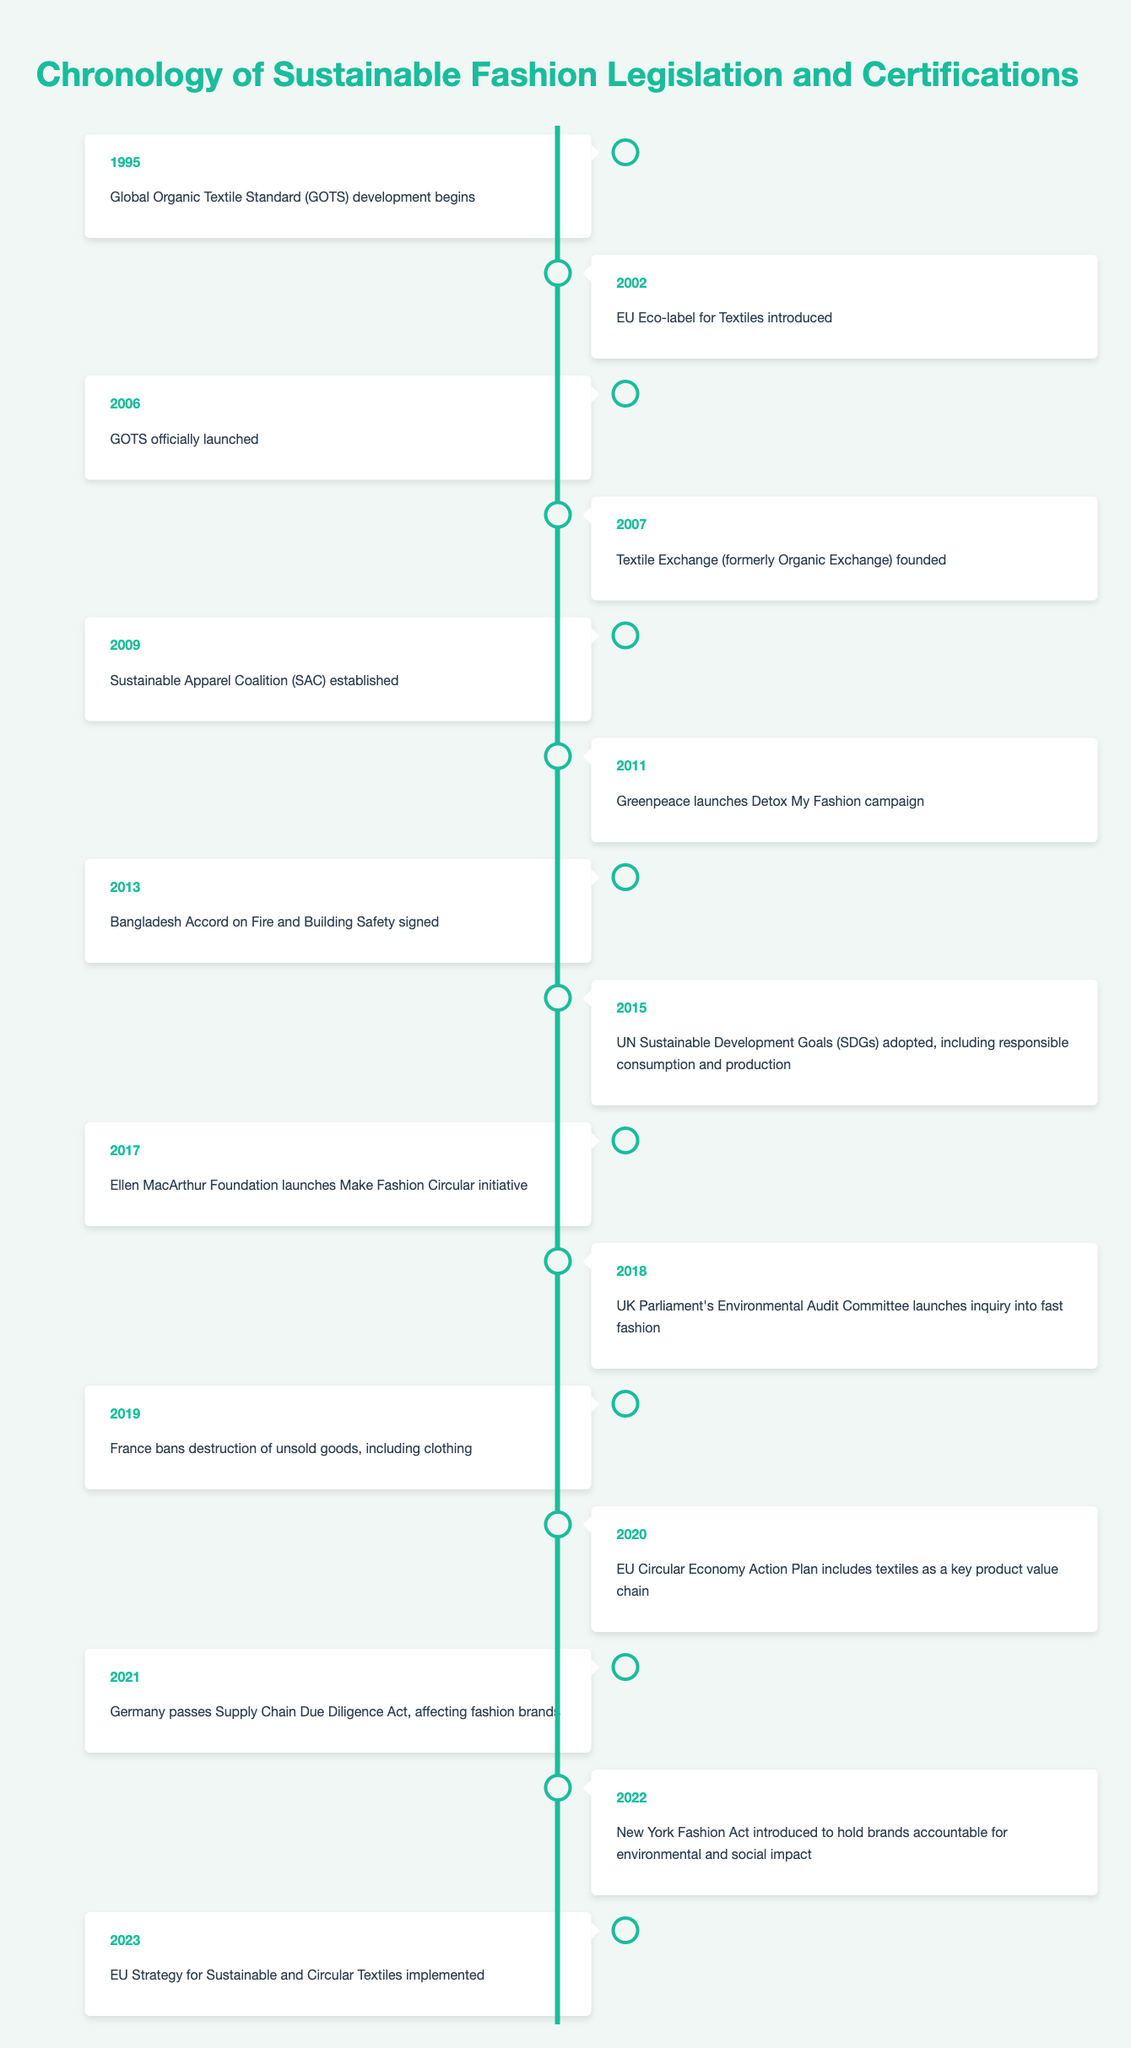What year did the Global Organic Textile Standard begin development? According to the timeline, the Global Organic Textile Standard (GOTS) development began in 1995.
Answer: 1995 What event is associated with the year 2019? The timeline indicates that in 2019, France banned the destruction of unsold goods, including clothing.
Answer: France bans destruction of unsold goods When was the EU Strategy for Sustainable and Circular Textiles implemented? The table states that the EU Strategy for Sustainable and Circular Textiles was implemented in 2023.
Answer: 2023 How many events related to sustainable fashion occurred between 2011 and 2018? From the timeline, there are 8 events listed between 2011 (starting with Greenpeace's campaign) and 2018 (ending with the UK inquiry into fast fashion). Counting those years gives us events for 2011, 2013, 2015, 2017, and 2018.
Answer: 8 Did the EU introduce an Eco-label for Textiles before the GOTS was officially launched? Yes, the EU Eco-label for Textiles was introduced in 2002, while GOTS was officially launched in 2006.
Answer: Yes Which event indicates a response to the fast fashion industry? The UK Parliament's Environmental Audit Committee launched an inquiry into fast fashion in 2018, signaling a governmental response to the fast fashion industry.
Answer: UK inquiry into fast fashion Which decade had the most sustainable fashion events listed? Examining the timeline, the 2010s (2011-2019) had the most events, totaling 7 significant events related to sustainable fashion.
Answer: 2010s What was the initiative launched by the Ellen MacArthur Foundation in 2017? The timeline states that in 2017, the Ellen MacArthur Foundation launched the Make Fashion Circular initiative aimed at promoting circular economy principles in fashion.
Answer: Make Fashion Circular initiative How does the number of events in the 2020s compare to the previous decade? There are 2 events in the 2020s (2020 and 2022), whereas there were 7 in the 2010s. This shows a decrease in the number of events.
Answer: 2 events in the 2020s; 7 in the 2010s 